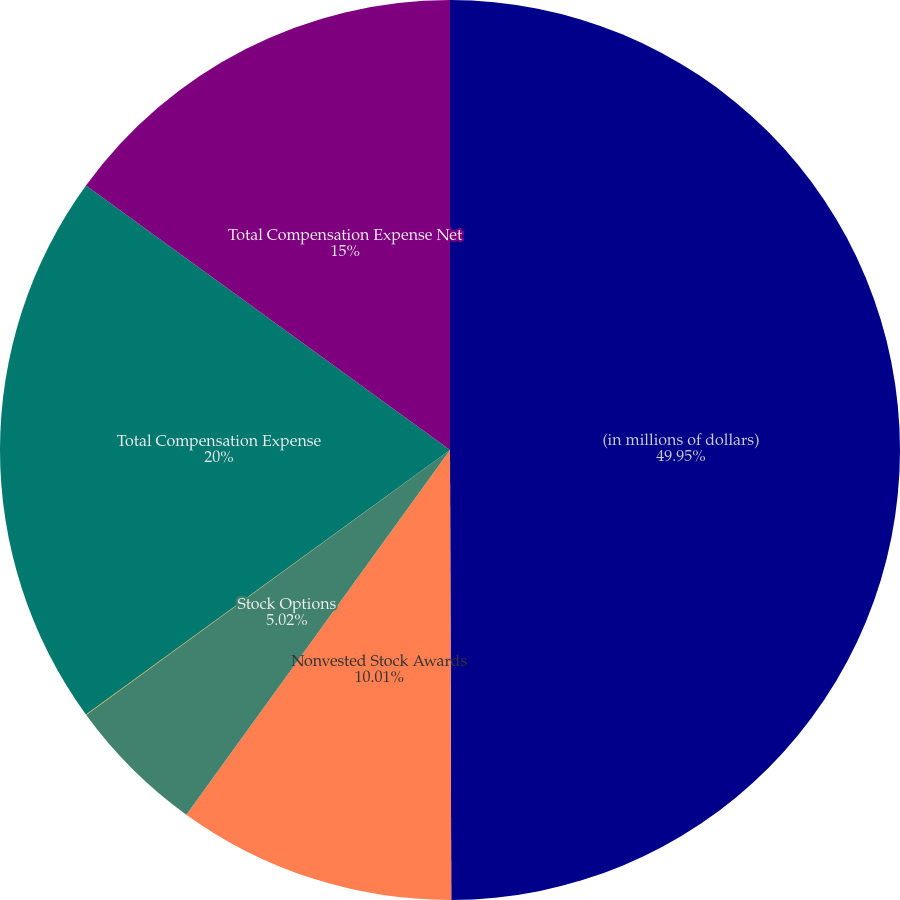Convert chart to OTSL. <chart><loc_0><loc_0><loc_500><loc_500><pie_chart><fcel>(in millions of dollars)<fcel>Nonvested Stock Awards<fcel>Stock Options<fcel>Employee Stock Purchase Plan<fcel>Total Compensation Expense<fcel>Total Compensation Expense Net<nl><fcel>49.96%<fcel>10.01%<fcel>5.02%<fcel>0.02%<fcel>20.0%<fcel>15.0%<nl></chart> 